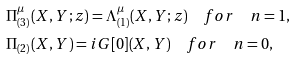<formula> <loc_0><loc_0><loc_500><loc_500>& \Pi _ { ( 3 ) } ^ { \mu } ( X , Y ; z ) = \Lambda _ { ( 1 ) } ^ { \mu } ( X , Y ; z ) \quad f o r \quad n = 1 , \\ & \Pi _ { ( 2 ) } ( X , Y ) = i G [ 0 ] ( X , Y ) \quad f o r \quad n = 0 ,</formula> 